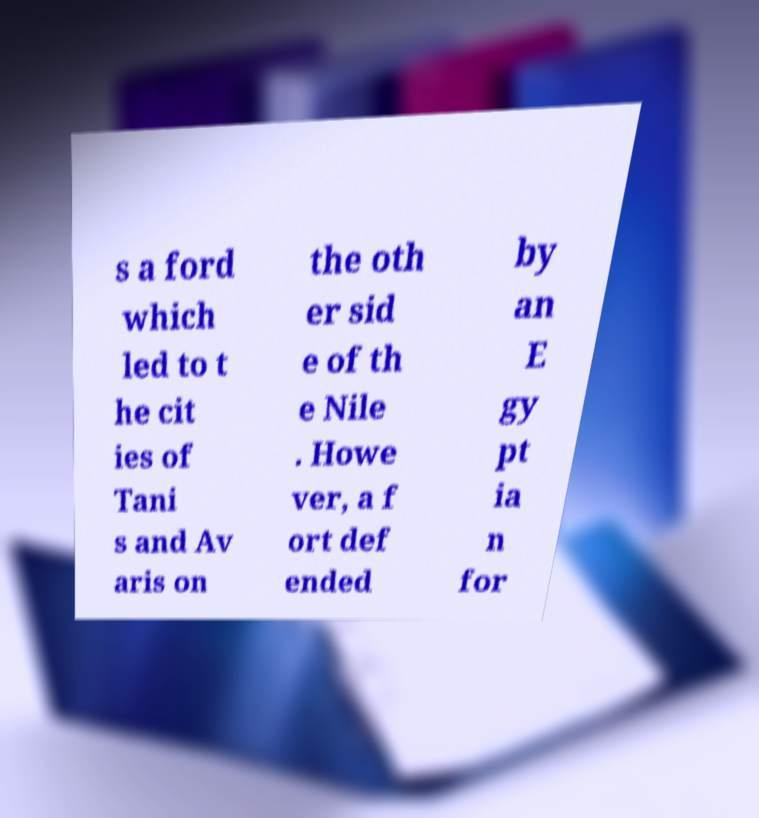Please read and relay the text visible in this image. What does it say? s a ford which led to t he cit ies of Tani s and Av aris on the oth er sid e of th e Nile . Howe ver, a f ort def ended by an E gy pt ia n for 